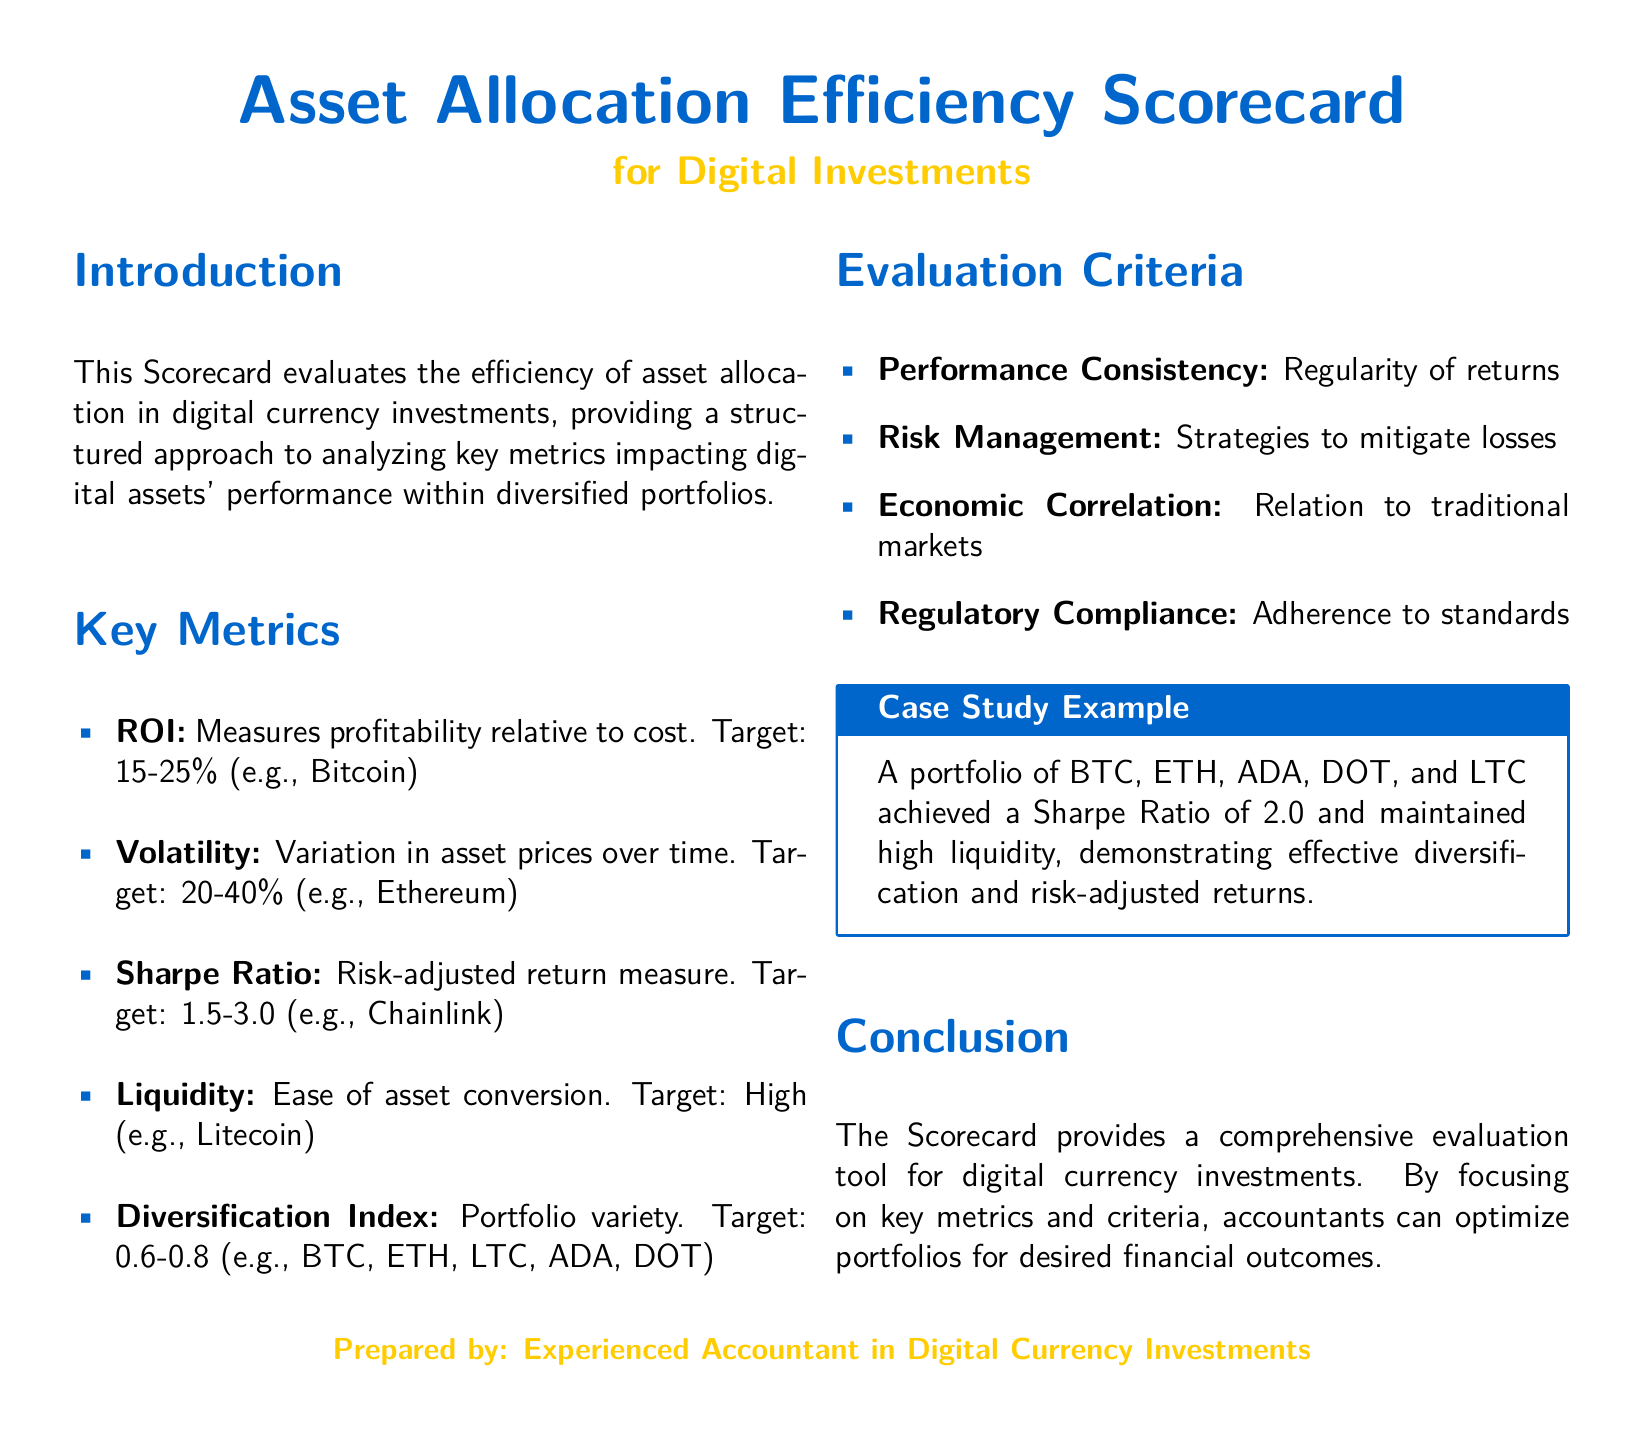What is the target ROI for digital investments? The target ROI is specified within the key metrics section of the document.
Answer: 15-25% What is the Sharpe Ratio target? The Sharpe Ratio target is mentioned in the key metrics and relates to risk-adjusted returns.
Answer: 1.5-3.0 Which digital asset is an example for high liquidity? The document provides examples of assets associated with each key metric, indicating an asset with high liquidity.
Answer: Litecoin What does the Diversification Index target range from? The target range is outlined under key metrics in the document.
Answer: 0.6-0.8 What was the Sharpe Ratio of the case study portfolio? This value is included in the case study example, indicating performance achievement.
Answer: 2.0 How many digital assets are included in the case study example? The case study lists a specific collection of assets for evaluation.
Answer: Five What key criterion relates to adherence to standards? This key evaluation criterion is explicitly stated in the document.
Answer: Regulatory Compliance What is assessed in the performance consistency criterion? This evaluation criterion focuses on a specific aspect of performance measurement.
Answer: Regularity of returns What type of document is this? The title at the beginning clarifies the nature of the document.
Answer: Scorecard 